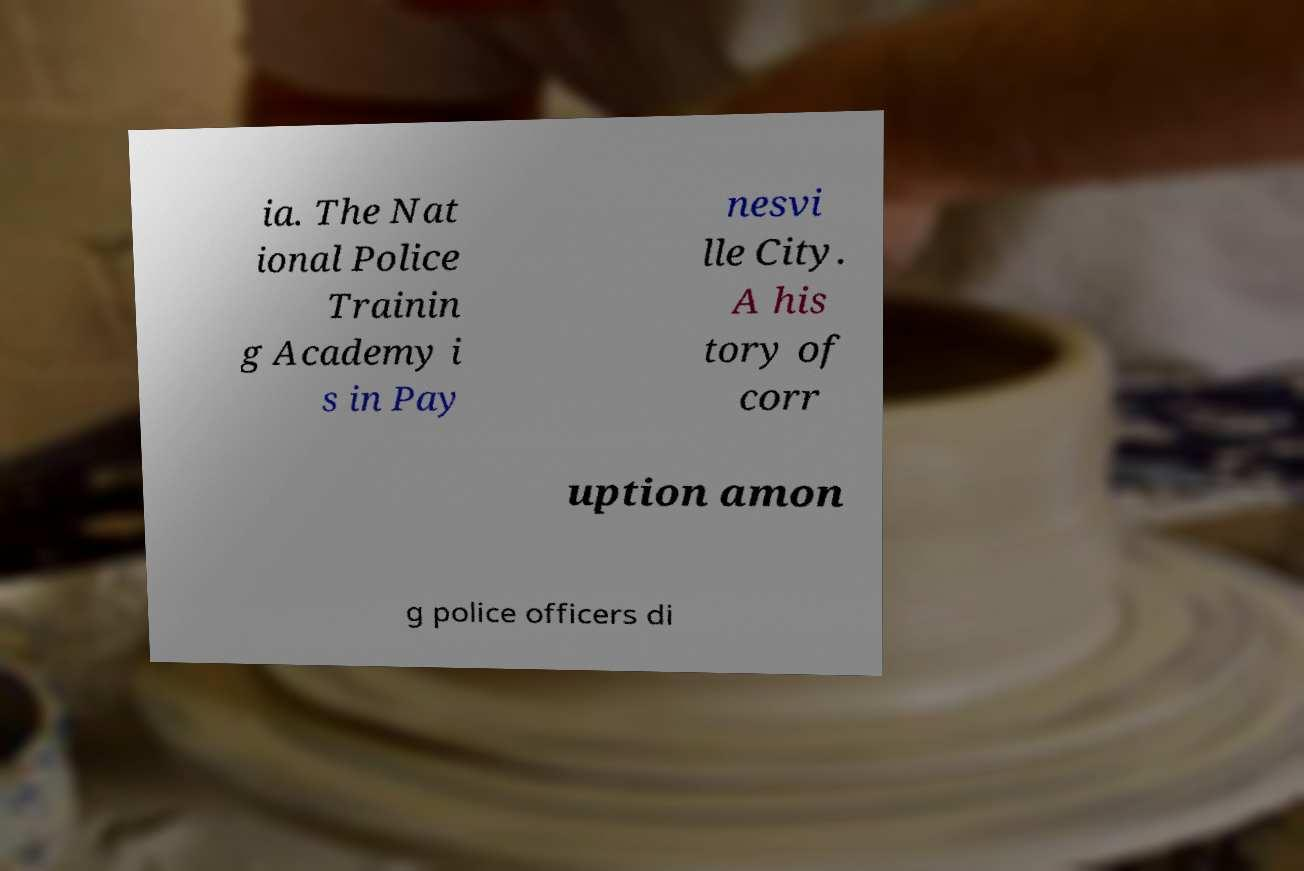Could you assist in decoding the text presented in this image and type it out clearly? ia. The Nat ional Police Trainin g Academy i s in Pay nesvi lle City. A his tory of corr uption amon g police officers di 